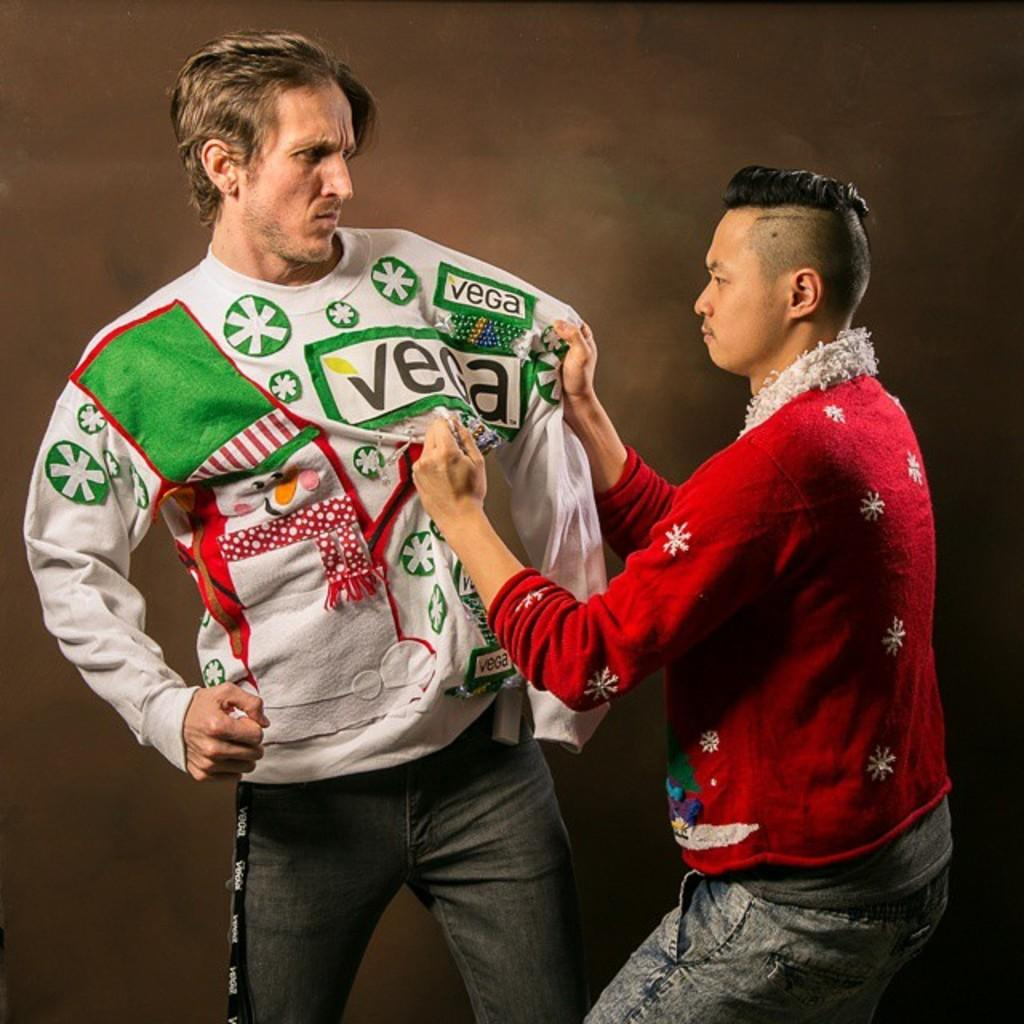<image>
Offer a succinct explanation of the picture presented. A man wearing a sweatshirt with Vega logos is having a hostile interaction with another man. 